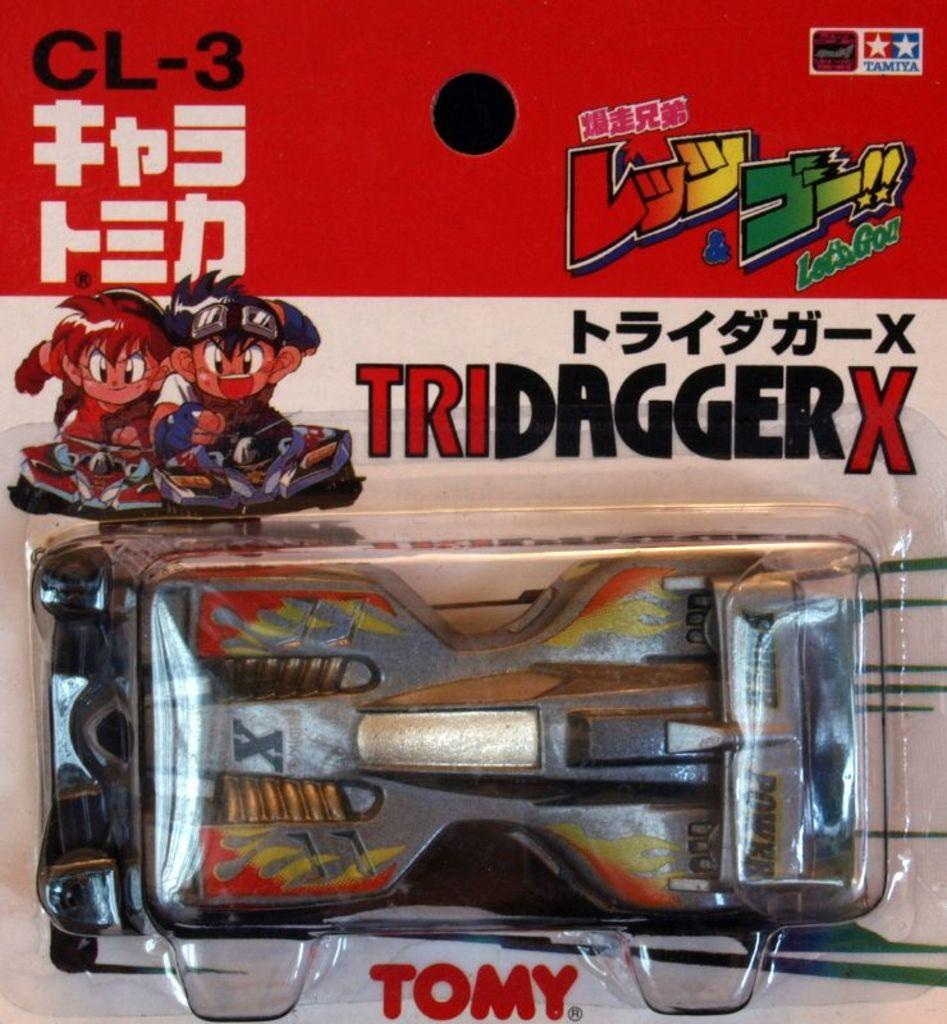What object is the main subject of the image? There is a toy car in the image. Where is the toy car located? The toy car is placed in a package. What type of hate can be seen on the toy car's face in the image? There is no face or expression on the toy car in the image, as it is a toy car and not a living being capable of expressing emotions. 